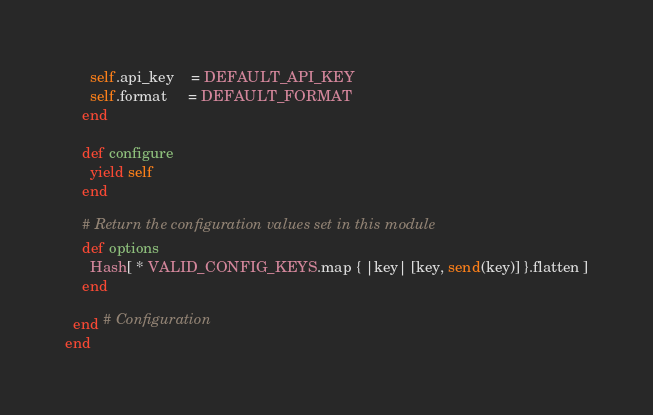Convert code to text. <code><loc_0><loc_0><loc_500><loc_500><_Ruby_>
      self.api_key    = DEFAULT_API_KEY
      self.format     = DEFAULT_FORMAT
    end

    def configure
      yield self
    end

    # Return the configuration values set in this module
    def options
      Hash[ * VALID_CONFIG_KEYS.map { |key| [key, send(key)] }.flatten ]
    end

  end # Configuration
end
</code> 